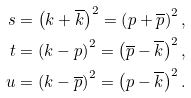Convert formula to latex. <formula><loc_0><loc_0><loc_500><loc_500>s & = \left ( k + \overline { k } \right ) ^ { 2 } = \left ( p + \overline { p } \right ) ^ { 2 } , \\ t & = \left ( k - p \right ) ^ { 2 } = \left ( \overline { p } - \overline { k } \right ) ^ { 2 } , \\ u & = \left ( k - \overline { p } \right ) ^ { 2 } = \left ( p - \overline { k } \right ) ^ { 2 } .</formula> 